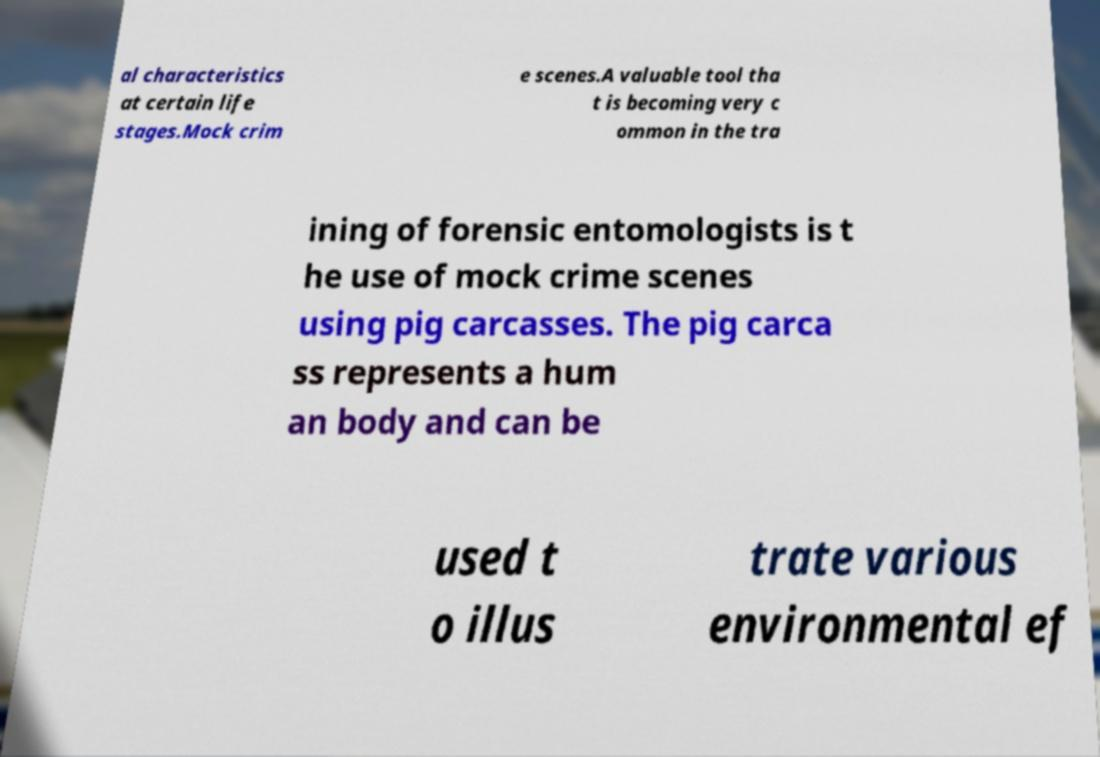There's text embedded in this image that I need extracted. Can you transcribe it verbatim? al characteristics at certain life stages.Mock crim e scenes.A valuable tool tha t is becoming very c ommon in the tra ining of forensic entomologists is t he use of mock crime scenes using pig carcasses. The pig carca ss represents a hum an body and can be used t o illus trate various environmental ef 